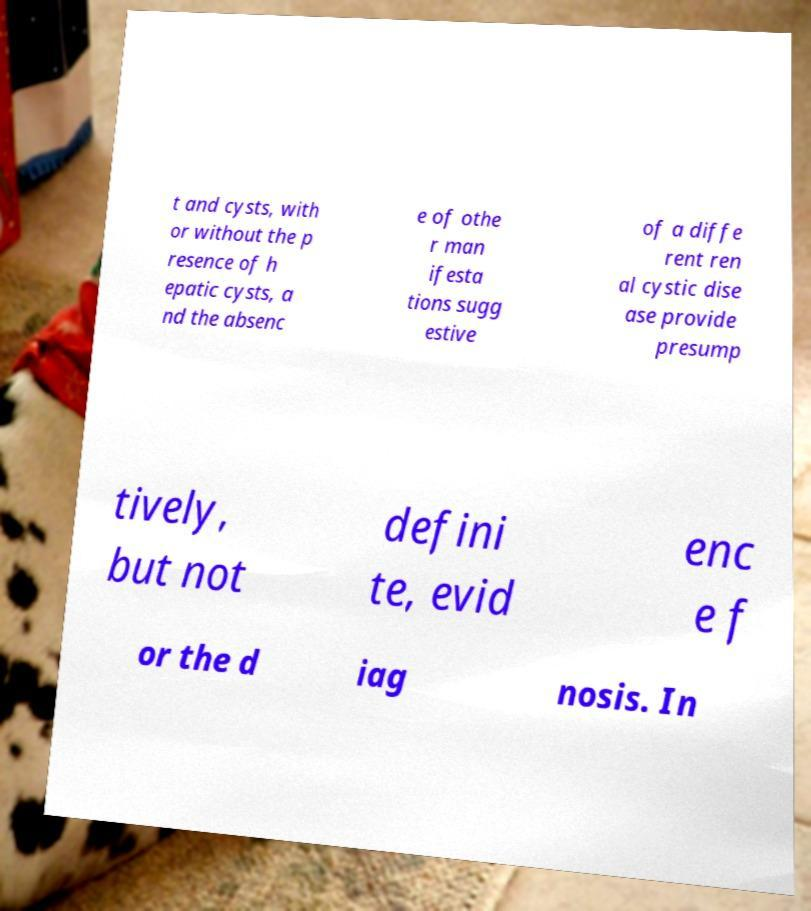What messages or text are displayed in this image? I need them in a readable, typed format. t and cysts, with or without the p resence of h epatic cysts, a nd the absenc e of othe r man ifesta tions sugg estive of a diffe rent ren al cystic dise ase provide presump tively, but not defini te, evid enc e f or the d iag nosis. In 